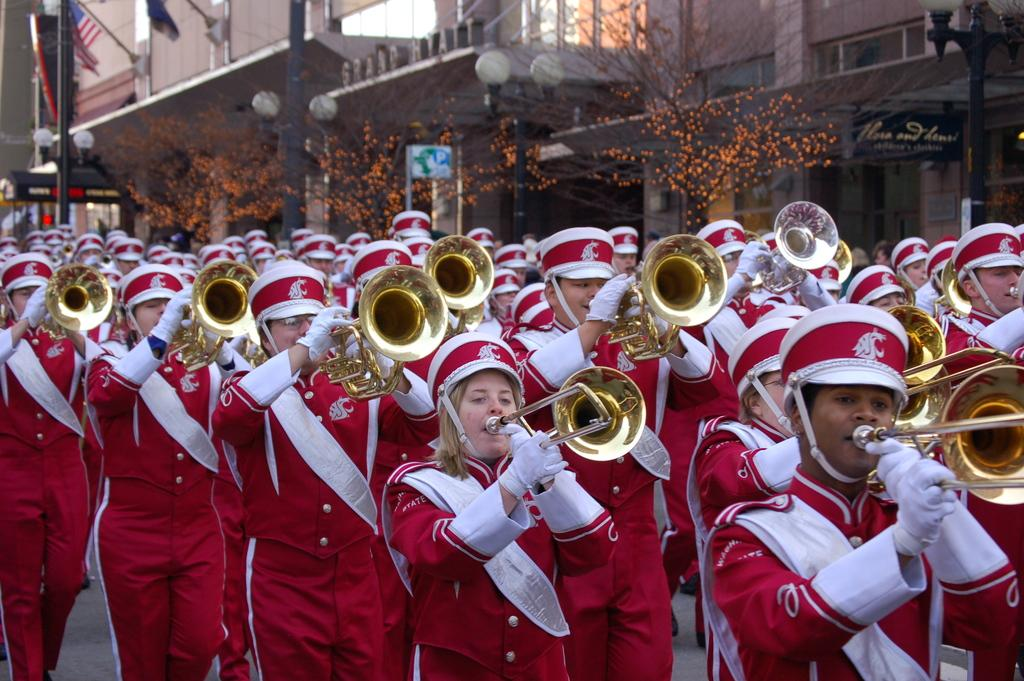What are the people in the image doing? People are playing musical instruments in the image. What can be seen in the background of the image? There are light poles, boards, flags, trees, and at least one building in the background of the image. Can you describe the objects in the background of the image? There are objects in the background of the image, but their specific nature is not mentioned in the facts. What type of crib is visible in the image? There is no crib present in the image. What note is being played by the person on the drum in the image? There is no drum or person playing a drum mentioned in the image. 